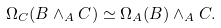Convert formula to latex. <formula><loc_0><loc_0><loc_500><loc_500>\Omega _ { C } ( B \wedge _ { A } C ) \simeq \Omega _ { A } ( B ) \wedge _ { A } C .</formula> 